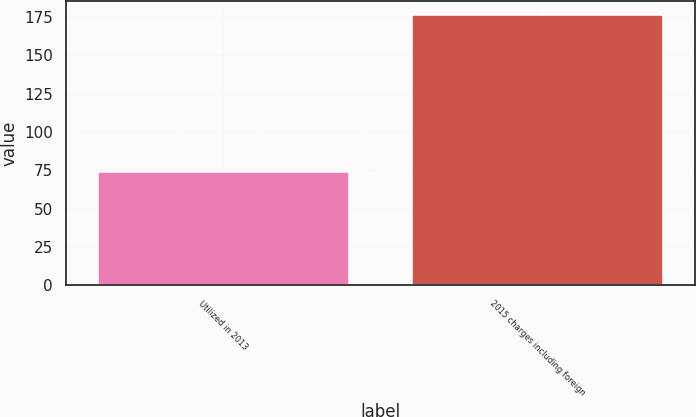Convert chart to OTSL. <chart><loc_0><loc_0><loc_500><loc_500><bar_chart><fcel>Utilized in 2013<fcel>2015 charges including foreign<nl><fcel>74.2<fcel>176.4<nl></chart> 